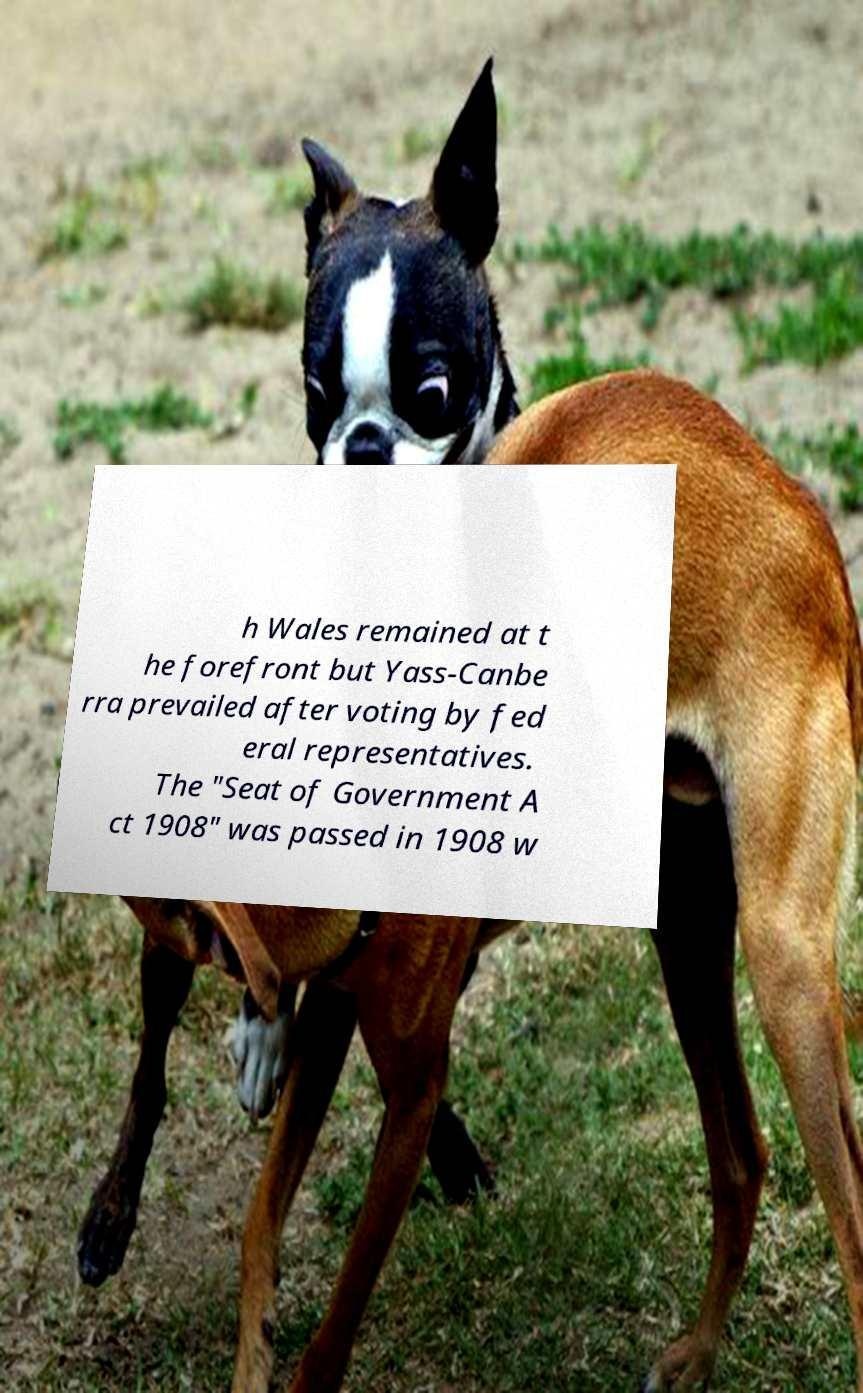Please identify and transcribe the text found in this image. h Wales remained at t he forefront but Yass-Canbe rra prevailed after voting by fed eral representatives. The "Seat of Government A ct 1908" was passed in 1908 w 